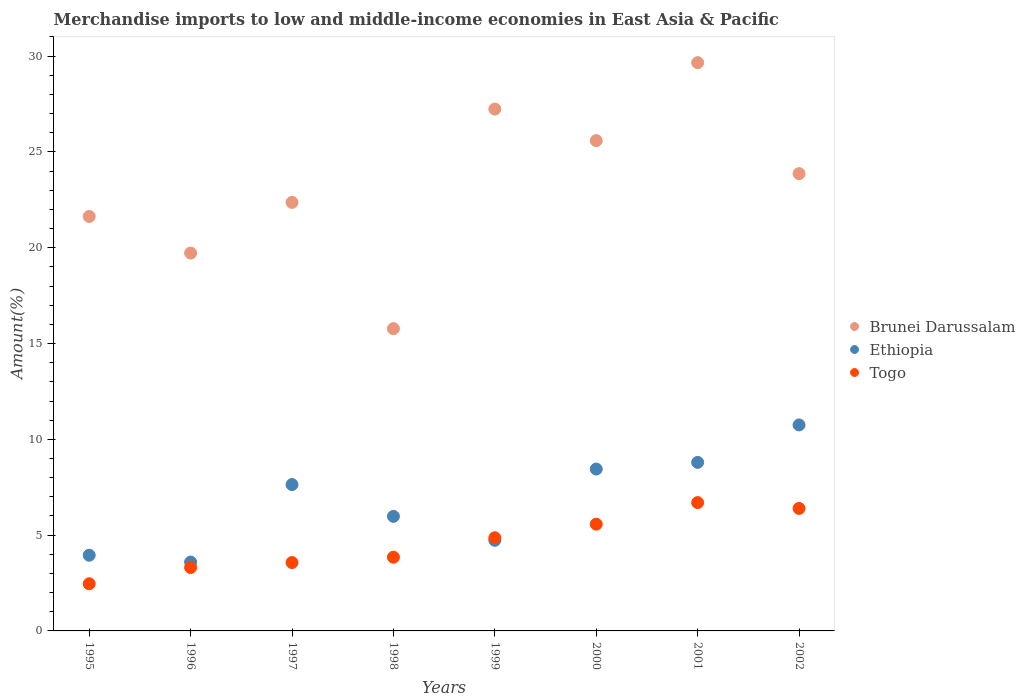How many different coloured dotlines are there?
Your response must be concise. 3. Is the number of dotlines equal to the number of legend labels?
Ensure brevity in your answer.  Yes. What is the percentage of amount earned from merchandise imports in Ethiopia in 1995?
Give a very brief answer. 3.95. Across all years, what is the maximum percentage of amount earned from merchandise imports in Ethiopia?
Keep it short and to the point. 10.75. Across all years, what is the minimum percentage of amount earned from merchandise imports in Brunei Darussalam?
Offer a terse response. 15.78. In which year was the percentage of amount earned from merchandise imports in Brunei Darussalam maximum?
Your response must be concise. 2001. In which year was the percentage of amount earned from merchandise imports in Brunei Darussalam minimum?
Offer a very short reply. 1998. What is the total percentage of amount earned from merchandise imports in Togo in the graph?
Provide a short and direct response. 36.71. What is the difference between the percentage of amount earned from merchandise imports in Ethiopia in 1996 and that in 1997?
Your answer should be compact. -4.04. What is the difference between the percentage of amount earned from merchandise imports in Togo in 1995 and the percentage of amount earned from merchandise imports in Brunei Darussalam in 2000?
Offer a terse response. -23.13. What is the average percentage of amount earned from merchandise imports in Togo per year?
Your response must be concise. 4.59. In the year 1997, what is the difference between the percentage of amount earned from merchandise imports in Togo and percentage of amount earned from merchandise imports in Ethiopia?
Keep it short and to the point. -4.07. What is the ratio of the percentage of amount earned from merchandise imports in Togo in 1995 to that in 2002?
Your response must be concise. 0.39. Is the percentage of amount earned from merchandise imports in Togo in 1997 less than that in 1999?
Your answer should be very brief. Yes. Is the difference between the percentage of amount earned from merchandise imports in Togo in 1998 and 2001 greater than the difference between the percentage of amount earned from merchandise imports in Ethiopia in 1998 and 2001?
Give a very brief answer. No. What is the difference between the highest and the second highest percentage of amount earned from merchandise imports in Togo?
Your answer should be compact. 0.3. What is the difference between the highest and the lowest percentage of amount earned from merchandise imports in Brunei Darussalam?
Give a very brief answer. 13.89. Is the sum of the percentage of amount earned from merchandise imports in Togo in 2000 and 2002 greater than the maximum percentage of amount earned from merchandise imports in Ethiopia across all years?
Give a very brief answer. Yes. Does the percentage of amount earned from merchandise imports in Togo monotonically increase over the years?
Ensure brevity in your answer.  No. Is the percentage of amount earned from merchandise imports in Ethiopia strictly less than the percentage of amount earned from merchandise imports in Brunei Darussalam over the years?
Keep it short and to the point. Yes. Are the values on the major ticks of Y-axis written in scientific E-notation?
Offer a very short reply. No. Does the graph contain any zero values?
Offer a terse response. No. Where does the legend appear in the graph?
Give a very brief answer. Center right. How many legend labels are there?
Your answer should be very brief. 3. How are the legend labels stacked?
Your answer should be compact. Vertical. What is the title of the graph?
Your response must be concise. Merchandise imports to low and middle-income economies in East Asia & Pacific. Does "St. Kitts and Nevis" appear as one of the legend labels in the graph?
Your answer should be compact. No. What is the label or title of the Y-axis?
Provide a succinct answer. Amount(%). What is the Amount(%) of Brunei Darussalam in 1995?
Your answer should be compact. 21.63. What is the Amount(%) in Ethiopia in 1995?
Your response must be concise. 3.95. What is the Amount(%) in Togo in 1995?
Offer a terse response. 2.46. What is the Amount(%) in Brunei Darussalam in 1996?
Give a very brief answer. 19.72. What is the Amount(%) of Ethiopia in 1996?
Make the answer very short. 3.59. What is the Amount(%) in Togo in 1996?
Make the answer very short. 3.31. What is the Amount(%) in Brunei Darussalam in 1997?
Ensure brevity in your answer.  22.37. What is the Amount(%) in Ethiopia in 1997?
Offer a terse response. 7.64. What is the Amount(%) of Togo in 1997?
Your answer should be very brief. 3.57. What is the Amount(%) of Brunei Darussalam in 1998?
Your response must be concise. 15.78. What is the Amount(%) of Ethiopia in 1998?
Offer a terse response. 5.98. What is the Amount(%) in Togo in 1998?
Keep it short and to the point. 3.85. What is the Amount(%) in Brunei Darussalam in 1999?
Provide a short and direct response. 27.24. What is the Amount(%) in Ethiopia in 1999?
Ensure brevity in your answer.  4.73. What is the Amount(%) of Togo in 1999?
Ensure brevity in your answer.  4.86. What is the Amount(%) in Brunei Darussalam in 2000?
Offer a terse response. 25.59. What is the Amount(%) in Ethiopia in 2000?
Provide a succinct answer. 8.45. What is the Amount(%) of Togo in 2000?
Offer a very short reply. 5.57. What is the Amount(%) in Brunei Darussalam in 2001?
Your response must be concise. 29.66. What is the Amount(%) in Ethiopia in 2001?
Offer a very short reply. 8.8. What is the Amount(%) in Togo in 2001?
Your answer should be very brief. 6.7. What is the Amount(%) of Brunei Darussalam in 2002?
Your answer should be very brief. 23.87. What is the Amount(%) of Ethiopia in 2002?
Your response must be concise. 10.75. What is the Amount(%) in Togo in 2002?
Your response must be concise. 6.39. Across all years, what is the maximum Amount(%) in Brunei Darussalam?
Make the answer very short. 29.66. Across all years, what is the maximum Amount(%) in Ethiopia?
Provide a succinct answer. 10.75. Across all years, what is the maximum Amount(%) in Togo?
Make the answer very short. 6.7. Across all years, what is the minimum Amount(%) in Brunei Darussalam?
Your answer should be compact. 15.78. Across all years, what is the minimum Amount(%) of Ethiopia?
Offer a terse response. 3.59. Across all years, what is the minimum Amount(%) of Togo?
Give a very brief answer. 2.46. What is the total Amount(%) in Brunei Darussalam in the graph?
Your answer should be compact. 185.85. What is the total Amount(%) of Ethiopia in the graph?
Give a very brief answer. 53.89. What is the total Amount(%) of Togo in the graph?
Your answer should be compact. 36.71. What is the difference between the Amount(%) in Brunei Darussalam in 1995 and that in 1996?
Offer a terse response. 1.91. What is the difference between the Amount(%) of Ethiopia in 1995 and that in 1996?
Your response must be concise. 0.36. What is the difference between the Amount(%) of Togo in 1995 and that in 1996?
Give a very brief answer. -0.85. What is the difference between the Amount(%) in Brunei Darussalam in 1995 and that in 1997?
Your answer should be very brief. -0.74. What is the difference between the Amount(%) in Ethiopia in 1995 and that in 1997?
Offer a very short reply. -3.69. What is the difference between the Amount(%) in Togo in 1995 and that in 1997?
Provide a short and direct response. -1.11. What is the difference between the Amount(%) of Brunei Darussalam in 1995 and that in 1998?
Your answer should be compact. 5.85. What is the difference between the Amount(%) of Ethiopia in 1995 and that in 1998?
Provide a short and direct response. -2.03. What is the difference between the Amount(%) in Togo in 1995 and that in 1998?
Offer a very short reply. -1.39. What is the difference between the Amount(%) in Brunei Darussalam in 1995 and that in 1999?
Give a very brief answer. -5.61. What is the difference between the Amount(%) in Ethiopia in 1995 and that in 1999?
Your response must be concise. -0.78. What is the difference between the Amount(%) in Togo in 1995 and that in 1999?
Ensure brevity in your answer.  -2.4. What is the difference between the Amount(%) in Brunei Darussalam in 1995 and that in 2000?
Make the answer very short. -3.96. What is the difference between the Amount(%) in Ethiopia in 1995 and that in 2000?
Ensure brevity in your answer.  -4.5. What is the difference between the Amount(%) of Togo in 1995 and that in 2000?
Your answer should be very brief. -3.11. What is the difference between the Amount(%) of Brunei Darussalam in 1995 and that in 2001?
Keep it short and to the point. -8.03. What is the difference between the Amount(%) in Ethiopia in 1995 and that in 2001?
Provide a succinct answer. -4.85. What is the difference between the Amount(%) of Togo in 1995 and that in 2001?
Keep it short and to the point. -4.24. What is the difference between the Amount(%) of Brunei Darussalam in 1995 and that in 2002?
Provide a succinct answer. -2.24. What is the difference between the Amount(%) of Ethiopia in 1995 and that in 2002?
Provide a short and direct response. -6.8. What is the difference between the Amount(%) of Togo in 1995 and that in 2002?
Offer a very short reply. -3.93. What is the difference between the Amount(%) in Brunei Darussalam in 1996 and that in 1997?
Offer a terse response. -2.65. What is the difference between the Amount(%) in Ethiopia in 1996 and that in 1997?
Ensure brevity in your answer.  -4.04. What is the difference between the Amount(%) in Togo in 1996 and that in 1997?
Ensure brevity in your answer.  -0.26. What is the difference between the Amount(%) in Brunei Darussalam in 1996 and that in 1998?
Provide a short and direct response. 3.95. What is the difference between the Amount(%) in Ethiopia in 1996 and that in 1998?
Keep it short and to the point. -2.38. What is the difference between the Amount(%) in Togo in 1996 and that in 1998?
Provide a short and direct response. -0.54. What is the difference between the Amount(%) of Brunei Darussalam in 1996 and that in 1999?
Keep it short and to the point. -7.52. What is the difference between the Amount(%) in Ethiopia in 1996 and that in 1999?
Ensure brevity in your answer.  -1.13. What is the difference between the Amount(%) of Togo in 1996 and that in 1999?
Your answer should be very brief. -1.56. What is the difference between the Amount(%) in Brunei Darussalam in 1996 and that in 2000?
Provide a succinct answer. -5.87. What is the difference between the Amount(%) of Ethiopia in 1996 and that in 2000?
Keep it short and to the point. -4.85. What is the difference between the Amount(%) of Togo in 1996 and that in 2000?
Offer a terse response. -2.26. What is the difference between the Amount(%) of Brunei Darussalam in 1996 and that in 2001?
Your answer should be compact. -9.94. What is the difference between the Amount(%) in Ethiopia in 1996 and that in 2001?
Provide a succinct answer. -5.2. What is the difference between the Amount(%) in Togo in 1996 and that in 2001?
Make the answer very short. -3.39. What is the difference between the Amount(%) in Brunei Darussalam in 1996 and that in 2002?
Keep it short and to the point. -4.15. What is the difference between the Amount(%) in Ethiopia in 1996 and that in 2002?
Ensure brevity in your answer.  -7.16. What is the difference between the Amount(%) in Togo in 1996 and that in 2002?
Your answer should be compact. -3.09. What is the difference between the Amount(%) in Brunei Darussalam in 1997 and that in 1998?
Offer a very short reply. 6.59. What is the difference between the Amount(%) of Ethiopia in 1997 and that in 1998?
Give a very brief answer. 1.66. What is the difference between the Amount(%) of Togo in 1997 and that in 1998?
Make the answer very short. -0.28. What is the difference between the Amount(%) of Brunei Darussalam in 1997 and that in 1999?
Provide a succinct answer. -4.87. What is the difference between the Amount(%) of Ethiopia in 1997 and that in 1999?
Keep it short and to the point. 2.91. What is the difference between the Amount(%) of Togo in 1997 and that in 1999?
Provide a succinct answer. -1.29. What is the difference between the Amount(%) in Brunei Darussalam in 1997 and that in 2000?
Make the answer very short. -3.22. What is the difference between the Amount(%) of Ethiopia in 1997 and that in 2000?
Offer a terse response. -0.81. What is the difference between the Amount(%) in Togo in 1997 and that in 2000?
Provide a succinct answer. -2. What is the difference between the Amount(%) in Brunei Darussalam in 1997 and that in 2001?
Give a very brief answer. -7.29. What is the difference between the Amount(%) in Ethiopia in 1997 and that in 2001?
Ensure brevity in your answer.  -1.16. What is the difference between the Amount(%) in Togo in 1997 and that in 2001?
Ensure brevity in your answer.  -3.13. What is the difference between the Amount(%) in Brunei Darussalam in 1997 and that in 2002?
Ensure brevity in your answer.  -1.5. What is the difference between the Amount(%) of Ethiopia in 1997 and that in 2002?
Offer a very short reply. -3.11. What is the difference between the Amount(%) of Togo in 1997 and that in 2002?
Ensure brevity in your answer.  -2.83. What is the difference between the Amount(%) in Brunei Darussalam in 1998 and that in 1999?
Offer a terse response. -11.46. What is the difference between the Amount(%) of Ethiopia in 1998 and that in 1999?
Ensure brevity in your answer.  1.25. What is the difference between the Amount(%) in Togo in 1998 and that in 1999?
Your answer should be compact. -1.02. What is the difference between the Amount(%) of Brunei Darussalam in 1998 and that in 2000?
Offer a terse response. -9.81. What is the difference between the Amount(%) of Ethiopia in 1998 and that in 2000?
Provide a short and direct response. -2.47. What is the difference between the Amount(%) of Togo in 1998 and that in 2000?
Provide a short and direct response. -1.72. What is the difference between the Amount(%) of Brunei Darussalam in 1998 and that in 2001?
Provide a short and direct response. -13.89. What is the difference between the Amount(%) in Ethiopia in 1998 and that in 2001?
Your answer should be compact. -2.82. What is the difference between the Amount(%) in Togo in 1998 and that in 2001?
Offer a terse response. -2.85. What is the difference between the Amount(%) in Brunei Darussalam in 1998 and that in 2002?
Give a very brief answer. -8.09. What is the difference between the Amount(%) of Ethiopia in 1998 and that in 2002?
Keep it short and to the point. -4.77. What is the difference between the Amount(%) in Togo in 1998 and that in 2002?
Offer a very short reply. -2.55. What is the difference between the Amount(%) of Brunei Darussalam in 1999 and that in 2000?
Provide a short and direct response. 1.65. What is the difference between the Amount(%) in Ethiopia in 1999 and that in 2000?
Your answer should be compact. -3.72. What is the difference between the Amount(%) in Togo in 1999 and that in 2000?
Ensure brevity in your answer.  -0.71. What is the difference between the Amount(%) of Brunei Darussalam in 1999 and that in 2001?
Your answer should be compact. -2.42. What is the difference between the Amount(%) of Ethiopia in 1999 and that in 2001?
Provide a succinct answer. -4.07. What is the difference between the Amount(%) of Togo in 1999 and that in 2001?
Your response must be concise. -1.84. What is the difference between the Amount(%) of Brunei Darussalam in 1999 and that in 2002?
Provide a succinct answer. 3.37. What is the difference between the Amount(%) in Ethiopia in 1999 and that in 2002?
Keep it short and to the point. -6.02. What is the difference between the Amount(%) of Togo in 1999 and that in 2002?
Keep it short and to the point. -1.53. What is the difference between the Amount(%) in Brunei Darussalam in 2000 and that in 2001?
Provide a succinct answer. -4.07. What is the difference between the Amount(%) in Ethiopia in 2000 and that in 2001?
Provide a short and direct response. -0.35. What is the difference between the Amount(%) of Togo in 2000 and that in 2001?
Provide a short and direct response. -1.13. What is the difference between the Amount(%) of Brunei Darussalam in 2000 and that in 2002?
Your answer should be very brief. 1.72. What is the difference between the Amount(%) of Ethiopia in 2000 and that in 2002?
Your answer should be compact. -2.3. What is the difference between the Amount(%) of Togo in 2000 and that in 2002?
Your answer should be compact. -0.82. What is the difference between the Amount(%) in Brunei Darussalam in 2001 and that in 2002?
Ensure brevity in your answer.  5.79. What is the difference between the Amount(%) of Ethiopia in 2001 and that in 2002?
Provide a succinct answer. -1.95. What is the difference between the Amount(%) of Togo in 2001 and that in 2002?
Provide a succinct answer. 0.3. What is the difference between the Amount(%) in Brunei Darussalam in 1995 and the Amount(%) in Ethiopia in 1996?
Ensure brevity in your answer.  18.04. What is the difference between the Amount(%) in Brunei Darussalam in 1995 and the Amount(%) in Togo in 1996?
Make the answer very short. 18.32. What is the difference between the Amount(%) in Ethiopia in 1995 and the Amount(%) in Togo in 1996?
Keep it short and to the point. 0.64. What is the difference between the Amount(%) in Brunei Darussalam in 1995 and the Amount(%) in Ethiopia in 1997?
Offer a very short reply. 13.99. What is the difference between the Amount(%) in Brunei Darussalam in 1995 and the Amount(%) in Togo in 1997?
Make the answer very short. 18.06. What is the difference between the Amount(%) in Ethiopia in 1995 and the Amount(%) in Togo in 1997?
Your response must be concise. 0.38. What is the difference between the Amount(%) in Brunei Darussalam in 1995 and the Amount(%) in Ethiopia in 1998?
Offer a terse response. 15.65. What is the difference between the Amount(%) of Brunei Darussalam in 1995 and the Amount(%) of Togo in 1998?
Your answer should be very brief. 17.78. What is the difference between the Amount(%) in Ethiopia in 1995 and the Amount(%) in Togo in 1998?
Keep it short and to the point. 0.1. What is the difference between the Amount(%) in Brunei Darussalam in 1995 and the Amount(%) in Ethiopia in 1999?
Provide a succinct answer. 16.9. What is the difference between the Amount(%) of Brunei Darussalam in 1995 and the Amount(%) of Togo in 1999?
Your response must be concise. 16.77. What is the difference between the Amount(%) in Ethiopia in 1995 and the Amount(%) in Togo in 1999?
Provide a succinct answer. -0.91. What is the difference between the Amount(%) of Brunei Darussalam in 1995 and the Amount(%) of Ethiopia in 2000?
Provide a short and direct response. 13.18. What is the difference between the Amount(%) of Brunei Darussalam in 1995 and the Amount(%) of Togo in 2000?
Offer a terse response. 16.06. What is the difference between the Amount(%) in Ethiopia in 1995 and the Amount(%) in Togo in 2000?
Ensure brevity in your answer.  -1.62. What is the difference between the Amount(%) in Brunei Darussalam in 1995 and the Amount(%) in Ethiopia in 2001?
Your answer should be compact. 12.83. What is the difference between the Amount(%) of Brunei Darussalam in 1995 and the Amount(%) of Togo in 2001?
Your response must be concise. 14.93. What is the difference between the Amount(%) of Ethiopia in 1995 and the Amount(%) of Togo in 2001?
Keep it short and to the point. -2.75. What is the difference between the Amount(%) of Brunei Darussalam in 1995 and the Amount(%) of Ethiopia in 2002?
Your answer should be very brief. 10.88. What is the difference between the Amount(%) of Brunei Darussalam in 1995 and the Amount(%) of Togo in 2002?
Keep it short and to the point. 15.24. What is the difference between the Amount(%) of Ethiopia in 1995 and the Amount(%) of Togo in 2002?
Your answer should be very brief. -2.44. What is the difference between the Amount(%) of Brunei Darussalam in 1996 and the Amount(%) of Ethiopia in 1997?
Make the answer very short. 12.08. What is the difference between the Amount(%) of Brunei Darussalam in 1996 and the Amount(%) of Togo in 1997?
Provide a succinct answer. 16.15. What is the difference between the Amount(%) of Ethiopia in 1996 and the Amount(%) of Togo in 1997?
Offer a terse response. 0.03. What is the difference between the Amount(%) of Brunei Darussalam in 1996 and the Amount(%) of Ethiopia in 1998?
Offer a very short reply. 13.74. What is the difference between the Amount(%) of Brunei Darussalam in 1996 and the Amount(%) of Togo in 1998?
Keep it short and to the point. 15.87. What is the difference between the Amount(%) of Ethiopia in 1996 and the Amount(%) of Togo in 1998?
Offer a terse response. -0.25. What is the difference between the Amount(%) of Brunei Darussalam in 1996 and the Amount(%) of Ethiopia in 1999?
Offer a terse response. 14.99. What is the difference between the Amount(%) in Brunei Darussalam in 1996 and the Amount(%) in Togo in 1999?
Your answer should be very brief. 14.86. What is the difference between the Amount(%) of Ethiopia in 1996 and the Amount(%) of Togo in 1999?
Your answer should be very brief. -1.27. What is the difference between the Amount(%) of Brunei Darussalam in 1996 and the Amount(%) of Ethiopia in 2000?
Offer a very short reply. 11.27. What is the difference between the Amount(%) in Brunei Darussalam in 1996 and the Amount(%) in Togo in 2000?
Your response must be concise. 14.15. What is the difference between the Amount(%) of Ethiopia in 1996 and the Amount(%) of Togo in 2000?
Provide a short and direct response. -1.98. What is the difference between the Amount(%) of Brunei Darussalam in 1996 and the Amount(%) of Ethiopia in 2001?
Give a very brief answer. 10.92. What is the difference between the Amount(%) in Brunei Darussalam in 1996 and the Amount(%) in Togo in 2001?
Provide a succinct answer. 13.02. What is the difference between the Amount(%) in Ethiopia in 1996 and the Amount(%) in Togo in 2001?
Your response must be concise. -3.1. What is the difference between the Amount(%) in Brunei Darussalam in 1996 and the Amount(%) in Ethiopia in 2002?
Give a very brief answer. 8.97. What is the difference between the Amount(%) of Brunei Darussalam in 1996 and the Amount(%) of Togo in 2002?
Provide a short and direct response. 13.33. What is the difference between the Amount(%) of Ethiopia in 1996 and the Amount(%) of Togo in 2002?
Offer a very short reply. -2.8. What is the difference between the Amount(%) of Brunei Darussalam in 1997 and the Amount(%) of Ethiopia in 1998?
Offer a very short reply. 16.39. What is the difference between the Amount(%) of Brunei Darussalam in 1997 and the Amount(%) of Togo in 1998?
Offer a very short reply. 18.52. What is the difference between the Amount(%) in Ethiopia in 1997 and the Amount(%) in Togo in 1998?
Your response must be concise. 3.79. What is the difference between the Amount(%) in Brunei Darussalam in 1997 and the Amount(%) in Ethiopia in 1999?
Your answer should be very brief. 17.64. What is the difference between the Amount(%) in Brunei Darussalam in 1997 and the Amount(%) in Togo in 1999?
Provide a short and direct response. 17.5. What is the difference between the Amount(%) in Ethiopia in 1997 and the Amount(%) in Togo in 1999?
Offer a very short reply. 2.78. What is the difference between the Amount(%) of Brunei Darussalam in 1997 and the Amount(%) of Ethiopia in 2000?
Offer a terse response. 13.92. What is the difference between the Amount(%) in Brunei Darussalam in 1997 and the Amount(%) in Togo in 2000?
Give a very brief answer. 16.8. What is the difference between the Amount(%) in Ethiopia in 1997 and the Amount(%) in Togo in 2000?
Offer a terse response. 2.07. What is the difference between the Amount(%) of Brunei Darussalam in 1997 and the Amount(%) of Ethiopia in 2001?
Provide a succinct answer. 13.57. What is the difference between the Amount(%) of Brunei Darussalam in 1997 and the Amount(%) of Togo in 2001?
Provide a succinct answer. 15.67. What is the difference between the Amount(%) in Ethiopia in 1997 and the Amount(%) in Togo in 2001?
Offer a terse response. 0.94. What is the difference between the Amount(%) in Brunei Darussalam in 1997 and the Amount(%) in Ethiopia in 2002?
Provide a succinct answer. 11.62. What is the difference between the Amount(%) of Brunei Darussalam in 1997 and the Amount(%) of Togo in 2002?
Keep it short and to the point. 15.97. What is the difference between the Amount(%) of Ethiopia in 1997 and the Amount(%) of Togo in 2002?
Give a very brief answer. 1.25. What is the difference between the Amount(%) of Brunei Darussalam in 1998 and the Amount(%) of Ethiopia in 1999?
Provide a short and direct response. 11.05. What is the difference between the Amount(%) of Brunei Darussalam in 1998 and the Amount(%) of Togo in 1999?
Offer a very short reply. 10.91. What is the difference between the Amount(%) in Ethiopia in 1998 and the Amount(%) in Togo in 1999?
Your response must be concise. 1.12. What is the difference between the Amount(%) of Brunei Darussalam in 1998 and the Amount(%) of Ethiopia in 2000?
Provide a short and direct response. 7.33. What is the difference between the Amount(%) of Brunei Darussalam in 1998 and the Amount(%) of Togo in 2000?
Provide a succinct answer. 10.2. What is the difference between the Amount(%) in Ethiopia in 1998 and the Amount(%) in Togo in 2000?
Provide a short and direct response. 0.41. What is the difference between the Amount(%) in Brunei Darussalam in 1998 and the Amount(%) in Ethiopia in 2001?
Keep it short and to the point. 6.98. What is the difference between the Amount(%) of Brunei Darussalam in 1998 and the Amount(%) of Togo in 2001?
Ensure brevity in your answer.  9.08. What is the difference between the Amount(%) in Ethiopia in 1998 and the Amount(%) in Togo in 2001?
Your response must be concise. -0.72. What is the difference between the Amount(%) of Brunei Darussalam in 1998 and the Amount(%) of Ethiopia in 2002?
Ensure brevity in your answer.  5.02. What is the difference between the Amount(%) of Brunei Darussalam in 1998 and the Amount(%) of Togo in 2002?
Offer a very short reply. 9.38. What is the difference between the Amount(%) of Ethiopia in 1998 and the Amount(%) of Togo in 2002?
Provide a short and direct response. -0.41. What is the difference between the Amount(%) of Brunei Darussalam in 1999 and the Amount(%) of Ethiopia in 2000?
Ensure brevity in your answer.  18.79. What is the difference between the Amount(%) of Brunei Darussalam in 1999 and the Amount(%) of Togo in 2000?
Your response must be concise. 21.67. What is the difference between the Amount(%) of Ethiopia in 1999 and the Amount(%) of Togo in 2000?
Provide a succinct answer. -0.84. What is the difference between the Amount(%) of Brunei Darussalam in 1999 and the Amount(%) of Ethiopia in 2001?
Offer a terse response. 18.44. What is the difference between the Amount(%) of Brunei Darussalam in 1999 and the Amount(%) of Togo in 2001?
Offer a terse response. 20.54. What is the difference between the Amount(%) of Ethiopia in 1999 and the Amount(%) of Togo in 2001?
Your answer should be compact. -1.97. What is the difference between the Amount(%) in Brunei Darussalam in 1999 and the Amount(%) in Ethiopia in 2002?
Provide a succinct answer. 16.49. What is the difference between the Amount(%) in Brunei Darussalam in 1999 and the Amount(%) in Togo in 2002?
Make the answer very short. 20.84. What is the difference between the Amount(%) of Ethiopia in 1999 and the Amount(%) of Togo in 2002?
Provide a succinct answer. -1.66. What is the difference between the Amount(%) of Brunei Darussalam in 2000 and the Amount(%) of Ethiopia in 2001?
Your answer should be very brief. 16.79. What is the difference between the Amount(%) of Brunei Darussalam in 2000 and the Amount(%) of Togo in 2001?
Your answer should be very brief. 18.89. What is the difference between the Amount(%) of Ethiopia in 2000 and the Amount(%) of Togo in 2001?
Your answer should be compact. 1.75. What is the difference between the Amount(%) in Brunei Darussalam in 2000 and the Amount(%) in Ethiopia in 2002?
Offer a terse response. 14.84. What is the difference between the Amount(%) in Brunei Darussalam in 2000 and the Amount(%) in Togo in 2002?
Provide a short and direct response. 19.2. What is the difference between the Amount(%) in Ethiopia in 2000 and the Amount(%) in Togo in 2002?
Offer a terse response. 2.05. What is the difference between the Amount(%) in Brunei Darussalam in 2001 and the Amount(%) in Ethiopia in 2002?
Make the answer very short. 18.91. What is the difference between the Amount(%) of Brunei Darussalam in 2001 and the Amount(%) of Togo in 2002?
Ensure brevity in your answer.  23.27. What is the difference between the Amount(%) of Ethiopia in 2001 and the Amount(%) of Togo in 2002?
Offer a very short reply. 2.4. What is the average Amount(%) of Brunei Darussalam per year?
Your answer should be very brief. 23.23. What is the average Amount(%) in Ethiopia per year?
Make the answer very short. 6.74. What is the average Amount(%) in Togo per year?
Give a very brief answer. 4.59. In the year 1995, what is the difference between the Amount(%) in Brunei Darussalam and Amount(%) in Ethiopia?
Offer a terse response. 17.68. In the year 1995, what is the difference between the Amount(%) of Brunei Darussalam and Amount(%) of Togo?
Keep it short and to the point. 19.17. In the year 1995, what is the difference between the Amount(%) of Ethiopia and Amount(%) of Togo?
Provide a succinct answer. 1.49. In the year 1996, what is the difference between the Amount(%) in Brunei Darussalam and Amount(%) in Ethiopia?
Your answer should be very brief. 16.13. In the year 1996, what is the difference between the Amount(%) of Brunei Darussalam and Amount(%) of Togo?
Make the answer very short. 16.41. In the year 1996, what is the difference between the Amount(%) of Ethiopia and Amount(%) of Togo?
Ensure brevity in your answer.  0.29. In the year 1997, what is the difference between the Amount(%) in Brunei Darussalam and Amount(%) in Ethiopia?
Provide a succinct answer. 14.73. In the year 1997, what is the difference between the Amount(%) of Brunei Darussalam and Amount(%) of Togo?
Your answer should be compact. 18.8. In the year 1997, what is the difference between the Amount(%) of Ethiopia and Amount(%) of Togo?
Keep it short and to the point. 4.07. In the year 1998, what is the difference between the Amount(%) in Brunei Darussalam and Amount(%) in Ethiopia?
Make the answer very short. 9.8. In the year 1998, what is the difference between the Amount(%) of Brunei Darussalam and Amount(%) of Togo?
Your response must be concise. 11.93. In the year 1998, what is the difference between the Amount(%) of Ethiopia and Amount(%) of Togo?
Provide a short and direct response. 2.13. In the year 1999, what is the difference between the Amount(%) in Brunei Darussalam and Amount(%) in Ethiopia?
Offer a terse response. 22.51. In the year 1999, what is the difference between the Amount(%) of Brunei Darussalam and Amount(%) of Togo?
Your response must be concise. 22.37. In the year 1999, what is the difference between the Amount(%) of Ethiopia and Amount(%) of Togo?
Your answer should be compact. -0.13. In the year 2000, what is the difference between the Amount(%) in Brunei Darussalam and Amount(%) in Ethiopia?
Your answer should be compact. 17.14. In the year 2000, what is the difference between the Amount(%) of Brunei Darussalam and Amount(%) of Togo?
Offer a very short reply. 20.02. In the year 2000, what is the difference between the Amount(%) of Ethiopia and Amount(%) of Togo?
Provide a short and direct response. 2.88. In the year 2001, what is the difference between the Amount(%) in Brunei Darussalam and Amount(%) in Ethiopia?
Your response must be concise. 20.86. In the year 2001, what is the difference between the Amount(%) in Brunei Darussalam and Amount(%) in Togo?
Make the answer very short. 22.96. In the year 2001, what is the difference between the Amount(%) of Ethiopia and Amount(%) of Togo?
Keep it short and to the point. 2.1. In the year 2002, what is the difference between the Amount(%) of Brunei Darussalam and Amount(%) of Ethiopia?
Provide a succinct answer. 13.12. In the year 2002, what is the difference between the Amount(%) of Brunei Darussalam and Amount(%) of Togo?
Keep it short and to the point. 17.47. In the year 2002, what is the difference between the Amount(%) of Ethiopia and Amount(%) of Togo?
Your answer should be compact. 4.36. What is the ratio of the Amount(%) in Brunei Darussalam in 1995 to that in 1996?
Provide a succinct answer. 1.1. What is the ratio of the Amount(%) of Ethiopia in 1995 to that in 1996?
Give a very brief answer. 1.1. What is the ratio of the Amount(%) of Togo in 1995 to that in 1996?
Give a very brief answer. 0.74. What is the ratio of the Amount(%) of Brunei Darussalam in 1995 to that in 1997?
Give a very brief answer. 0.97. What is the ratio of the Amount(%) in Ethiopia in 1995 to that in 1997?
Ensure brevity in your answer.  0.52. What is the ratio of the Amount(%) in Togo in 1995 to that in 1997?
Offer a very short reply. 0.69. What is the ratio of the Amount(%) of Brunei Darussalam in 1995 to that in 1998?
Give a very brief answer. 1.37. What is the ratio of the Amount(%) of Ethiopia in 1995 to that in 1998?
Your response must be concise. 0.66. What is the ratio of the Amount(%) in Togo in 1995 to that in 1998?
Provide a short and direct response. 0.64. What is the ratio of the Amount(%) in Brunei Darussalam in 1995 to that in 1999?
Offer a terse response. 0.79. What is the ratio of the Amount(%) in Ethiopia in 1995 to that in 1999?
Keep it short and to the point. 0.84. What is the ratio of the Amount(%) of Togo in 1995 to that in 1999?
Your answer should be very brief. 0.51. What is the ratio of the Amount(%) of Brunei Darussalam in 1995 to that in 2000?
Keep it short and to the point. 0.85. What is the ratio of the Amount(%) of Ethiopia in 1995 to that in 2000?
Offer a very short reply. 0.47. What is the ratio of the Amount(%) of Togo in 1995 to that in 2000?
Your response must be concise. 0.44. What is the ratio of the Amount(%) of Brunei Darussalam in 1995 to that in 2001?
Provide a succinct answer. 0.73. What is the ratio of the Amount(%) of Ethiopia in 1995 to that in 2001?
Provide a succinct answer. 0.45. What is the ratio of the Amount(%) in Togo in 1995 to that in 2001?
Your answer should be very brief. 0.37. What is the ratio of the Amount(%) of Brunei Darussalam in 1995 to that in 2002?
Keep it short and to the point. 0.91. What is the ratio of the Amount(%) in Ethiopia in 1995 to that in 2002?
Provide a short and direct response. 0.37. What is the ratio of the Amount(%) of Togo in 1995 to that in 2002?
Provide a succinct answer. 0.39. What is the ratio of the Amount(%) in Brunei Darussalam in 1996 to that in 1997?
Ensure brevity in your answer.  0.88. What is the ratio of the Amount(%) in Ethiopia in 1996 to that in 1997?
Your answer should be compact. 0.47. What is the ratio of the Amount(%) in Togo in 1996 to that in 1997?
Keep it short and to the point. 0.93. What is the ratio of the Amount(%) of Brunei Darussalam in 1996 to that in 1998?
Your answer should be very brief. 1.25. What is the ratio of the Amount(%) in Ethiopia in 1996 to that in 1998?
Ensure brevity in your answer.  0.6. What is the ratio of the Amount(%) in Togo in 1996 to that in 1998?
Keep it short and to the point. 0.86. What is the ratio of the Amount(%) of Brunei Darussalam in 1996 to that in 1999?
Your answer should be compact. 0.72. What is the ratio of the Amount(%) of Ethiopia in 1996 to that in 1999?
Keep it short and to the point. 0.76. What is the ratio of the Amount(%) in Togo in 1996 to that in 1999?
Ensure brevity in your answer.  0.68. What is the ratio of the Amount(%) in Brunei Darussalam in 1996 to that in 2000?
Your answer should be compact. 0.77. What is the ratio of the Amount(%) of Ethiopia in 1996 to that in 2000?
Your response must be concise. 0.43. What is the ratio of the Amount(%) in Togo in 1996 to that in 2000?
Provide a short and direct response. 0.59. What is the ratio of the Amount(%) of Brunei Darussalam in 1996 to that in 2001?
Provide a short and direct response. 0.66. What is the ratio of the Amount(%) in Ethiopia in 1996 to that in 2001?
Ensure brevity in your answer.  0.41. What is the ratio of the Amount(%) in Togo in 1996 to that in 2001?
Ensure brevity in your answer.  0.49. What is the ratio of the Amount(%) of Brunei Darussalam in 1996 to that in 2002?
Provide a short and direct response. 0.83. What is the ratio of the Amount(%) of Ethiopia in 1996 to that in 2002?
Ensure brevity in your answer.  0.33. What is the ratio of the Amount(%) in Togo in 1996 to that in 2002?
Ensure brevity in your answer.  0.52. What is the ratio of the Amount(%) in Brunei Darussalam in 1997 to that in 1998?
Provide a short and direct response. 1.42. What is the ratio of the Amount(%) in Ethiopia in 1997 to that in 1998?
Give a very brief answer. 1.28. What is the ratio of the Amount(%) of Togo in 1997 to that in 1998?
Provide a short and direct response. 0.93. What is the ratio of the Amount(%) in Brunei Darussalam in 1997 to that in 1999?
Offer a very short reply. 0.82. What is the ratio of the Amount(%) in Ethiopia in 1997 to that in 1999?
Provide a succinct answer. 1.62. What is the ratio of the Amount(%) in Togo in 1997 to that in 1999?
Keep it short and to the point. 0.73. What is the ratio of the Amount(%) of Brunei Darussalam in 1997 to that in 2000?
Your answer should be compact. 0.87. What is the ratio of the Amount(%) in Ethiopia in 1997 to that in 2000?
Give a very brief answer. 0.9. What is the ratio of the Amount(%) of Togo in 1997 to that in 2000?
Offer a very short reply. 0.64. What is the ratio of the Amount(%) in Brunei Darussalam in 1997 to that in 2001?
Provide a succinct answer. 0.75. What is the ratio of the Amount(%) of Ethiopia in 1997 to that in 2001?
Offer a very short reply. 0.87. What is the ratio of the Amount(%) of Togo in 1997 to that in 2001?
Give a very brief answer. 0.53. What is the ratio of the Amount(%) in Brunei Darussalam in 1997 to that in 2002?
Offer a terse response. 0.94. What is the ratio of the Amount(%) of Ethiopia in 1997 to that in 2002?
Keep it short and to the point. 0.71. What is the ratio of the Amount(%) of Togo in 1997 to that in 2002?
Make the answer very short. 0.56. What is the ratio of the Amount(%) in Brunei Darussalam in 1998 to that in 1999?
Give a very brief answer. 0.58. What is the ratio of the Amount(%) of Ethiopia in 1998 to that in 1999?
Ensure brevity in your answer.  1.26. What is the ratio of the Amount(%) of Togo in 1998 to that in 1999?
Ensure brevity in your answer.  0.79. What is the ratio of the Amount(%) in Brunei Darussalam in 1998 to that in 2000?
Ensure brevity in your answer.  0.62. What is the ratio of the Amount(%) in Ethiopia in 1998 to that in 2000?
Make the answer very short. 0.71. What is the ratio of the Amount(%) in Togo in 1998 to that in 2000?
Make the answer very short. 0.69. What is the ratio of the Amount(%) in Brunei Darussalam in 1998 to that in 2001?
Offer a terse response. 0.53. What is the ratio of the Amount(%) of Ethiopia in 1998 to that in 2001?
Ensure brevity in your answer.  0.68. What is the ratio of the Amount(%) in Togo in 1998 to that in 2001?
Give a very brief answer. 0.57. What is the ratio of the Amount(%) of Brunei Darussalam in 1998 to that in 2002?
Offer a terse response. 0.66. What is the ratio of the Amount(%) in Ethiopia in 1998 to that in 2002?
Your response must be concise. 0.56. What is the ratio of the Amount(%) of Togo in 1998 to that in 2002?
Make the answer very short. 0.6. What is the ratio of the Amount(%) of Brunei Darussalam in 1999 to that in 2000?
Your response must be concise. 1.06. What is the ratio of the Amount(%) in Ethiopia in 1999 to that in 2000?
Ensure brevity in your answer.  0.56. What is the ratio of the Amount(%) of Togo in 1999 to that in 2000?
Give a very brief answer. 0.87. What is the ratio of the Amount(%) of Brunei Darussalam in 1999 to that in 2001?
Your answer should be very brief. 0.92. What is the ratio of the Amount(%) of Ethiopia in 1999 to that in 2001?
Your answer should be compact. 0.54. What is the ratio of the Amount(%) in Togo in 1999 to that in 2001?
Keep it short and to the point. 0.73. What is the ratio of the Amount(%) in Brunei Darussalam in 1999 to that in 2002?
Ensure brevity in your answer.  1.14. What is the ratio of the Amount(%) of Ethiopia in 1999 to that in 2002?
Keep it short and to the point. 0.44. What is the ratio of the Amount(%) of Togo in 1999 to that in 2002?
Ensure brevity in your answer.  0.76. What is the ratio of the Amount(%) of Brunei Darussalam in 2000 to that in 2001?
Ensure brevity in your answer.  0.86. What is the ratio of the Amount(%) of Ethiopia in 2000 to that in 2001?
Give a very brief answer. 0.96. What is the ratio of the Amount(%) in Togo in 2000 to that in 2001?
Provide a succinct answer. 0.83. What is the ratio of the Amount(%) in Brunei Darussalam in 2000 to that in 2002?
Your answer should be compact. 1.07. What is the ratio of the Amount(%) in Ethiopia in 2000 to that in 2002?
Offer a very short reply. 0.79. What is the ratio of the Amount(%) of Togo in 2000 to that in 2002?
Offer a terse response. 0.87. What is the ratio of the Amount(%) in Brunei Darussalam in 2001 to that in 2002?
Ensure brevity in your answer.  1.24. What is the ratio of the Amount(%) of Ethiopia in 2001 to that in 2002?
Keep it short and to the point. 0.82. What is the ratio of the Amount(%) of Togo in 2001 to that in 2002?
Offer a very short reply. 1.05. What is the difference between the highest and the second highest Amount(%) of Brunei Darussalam?
Ensure brevity in your answer.  2.42. What is the difference between the highest and the second highest Amount(%) in Ethiopia?
Give a very brief answer. 1.95. What is the difference between the highest and the second highest Amount(%) of Togo?
Provide a succinct answer. 0.3. What is the difference between the highest and the lowest Amount(%) of Brunei Darussalam?
Your answer should be compact. 13.89. What is the difference between the highest and the lowest Amount(%) of Ethiopia?
Your response must be concise. 7.16. What is the difference between the highest and the lowest Amount(%) of Togo?
Offer a very short reply. 4.24. 